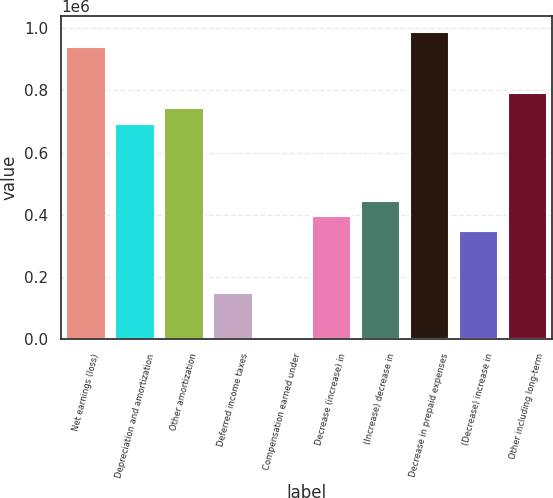Convert chart. <chart><loc_0><loc_0><loc_500><loc_500><bar_chart><fcel>Net earnings (loss)<fcel>Depreciation and amortization<fcel>Other amortization<fcel>Deferred income taxes<fcel>Compensation earned under<fcel>Decrease (increase) in<fcel>(Increase) decrease in<fcel>Decrease in prepaid expenses<fcel>(Decrease) increase in<fcel>Other including long-term<nl><fcel>939614<fcel>692813<fcel>742173<fcel>149851<fcel>1770<fcel>396652<fcel>446012<fcel>988974<fcel>347291<fcel>791533<nl></chart> 